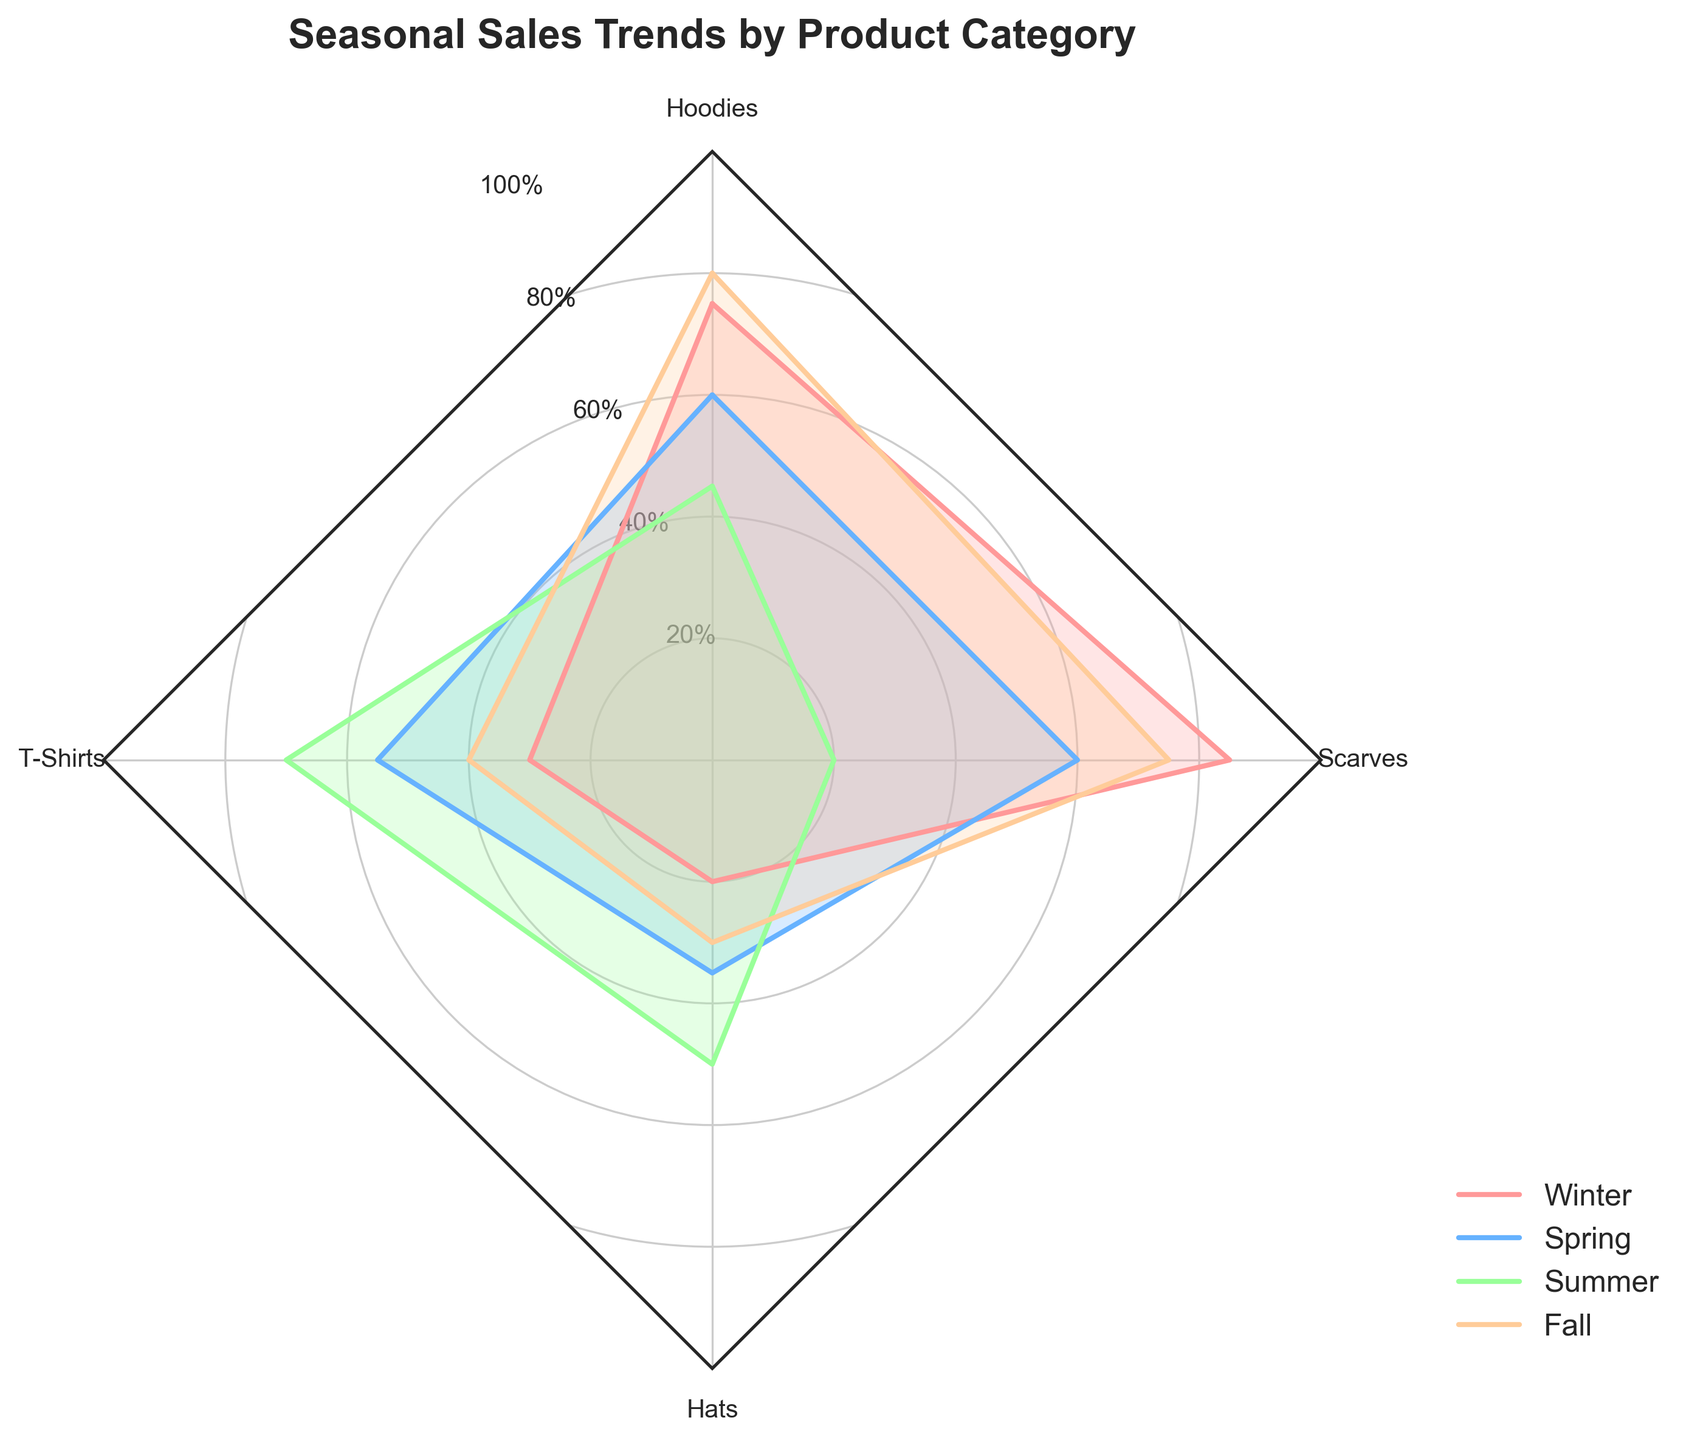Which product category has the highest sales in Winter? By observing the radar chart, we can see that Scarves have the highest value for the Winter season, which is 85%.
Answer: Scarves Which season has the lowest sales for T-Shirts? By observing the T-Shirts values on the radar chart, we see that Winter has the lowest sales value, which is 30%.
Answer: Winter How do the Winter sales of Hoodies compare to the Summer sales of Scarves? Check the values for Hoodies in Winter and Scarves in Summer on the radar chart. Hoodies in Winter have a value of 75%, while Scarves in Summer have a value of 20%. Thus, Hoodies in Winter have a higher sales value.
Answer: Hoodies in Winter are higher What is the average sales value across the four seasons for Hats? Summing up the values for Hats (20 + 35 + 50 + 30) gives us 135. Dividing 135 by 4 (number of seasons) gives us 33.75.
Answer: 33.75% Which product category has the most consistent sales across all seasons? By assessing the range of sales values for each product category in the radar chart, T-Shirts show the smallest variability (30 to 70) compared to others, indicating more consistent sales.
Answer: T-Shirts In which season are Hoodies outperforming T-Shirts by the largest margin? Check the values on the radar chart. In Fall, Hoodies have 80% and T-Shirts have 40%, making a difference of 40%. This is the largest margin.
Answer: Fall If the Summer sales for Hats increased by 10%, how would its value compare then to the current Summer sales of T-Shirts? Adding 10% to Hats' Summer sales (50 + 10 = 60). Now, comparing this with the T-Shirts Summer sales, which is 70%, Hats would still be lower.
Answer: T-Shirts would still be higher Which season shows the largest decline in sales for Scarves compared to the previous season? By checking the radar chart values for Scarves in consecutive seasons, Summer (20%) shows the largest decline from Spring (60%), with a difference of 40%.
Answer: Summer What is the cumulative sales percentage of Hoodies and Hats in Spring? Adding the Spring values for Hoodies (60) and Hats (35) gives us a cumulative sales percentage of 95%.
Answer: 95% Identify the product category that has the highest variability in sales throughout the seasons. By observing the radar chart, Scarves have the highest fluctuation from Winter (85) to Summer (20), indicating the highest variability across seasons.
Answer: Scarves 